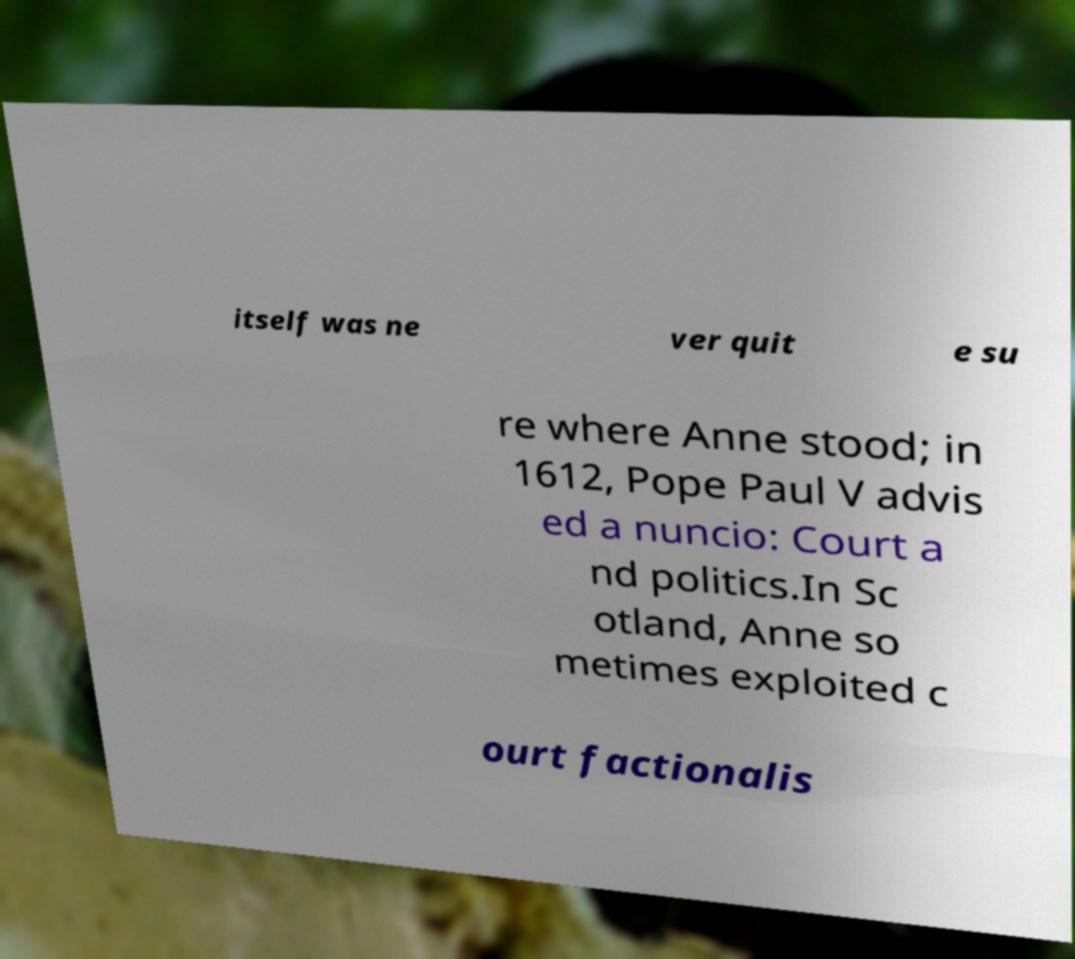I need the written content from this picture converted into text. Can you do that? itself was ne ver quit e su re where Anne stood; in 1612, Pope Paul V advis ed a nuncio: Court a nd politics.In Sc otland, Anne so metimes exploited c ourt factionalis 